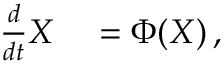Convert formula to latex. <formula><loc_0><loc_0><loc_500><loc_500>\begin{array} { r l } { \frac { d } { d t } X } & = \Phi ( X ) \, , } \end{array}</formula> 